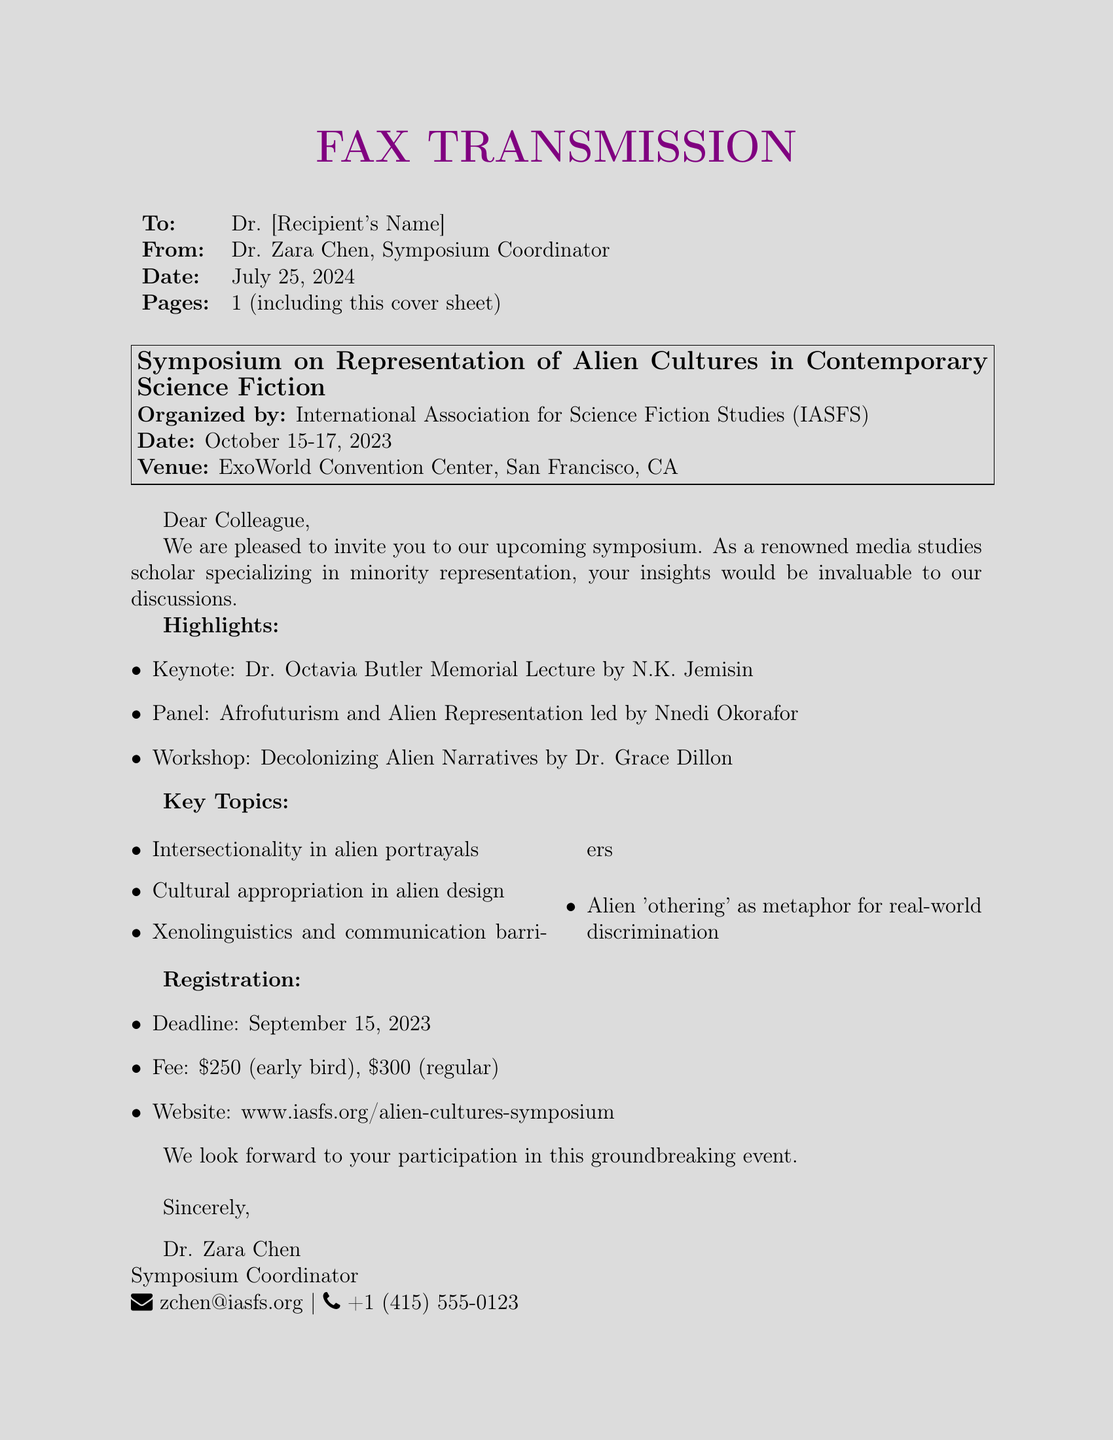What is the date of the symposium? The date of the symposium is specifically mentioned in the document as October 15-17, 2023.
Answer: October 15-17, 2023 Who is giving the keynote lecture? The document states that the keynote lecture is given by N.K. Jemisin in honor of Dr. Octavia Butler.
Answer: N.K. Jemisin What is the registration deadline? The registration deadline is clearly specified in the document as September 15, 2023.
Answer: September 15, 2023 What is the early bird registration fee? The document lists the early bird registration fee as $250.
Answer: $250 What is one of the key topics discussed during the symposium? The document mentions several key topics, including "Alien 'othering' as metaphor for real-world discrimination."
Answer: Alien 'othering' as metaphor for real-world discrimination Why might Dr. Zara Chen have targeted renowned media studies scholars for invitations? The document explains that insights from renowned media studies scholars, especially those specializing in minority representation, would be invaluable to discussions at the symposium.
Answer: Valuable insights What organization is organizing the symposium? The document indicates that the symposium is organized by the International Association for Science Fiction Studies (IASFS).
Answer: International Association for Science Fiction Studies (IASFS) What venue will the symposium be held at? The venue for the symposium is stated in the document as the ExoWorld Convention Center in San Francisco, CA.
Answer: ExoWorld Convention Center, San Francisco, CA How many pages does the fax consist of? The document specifies that the fax comprises one page, including the cover sheet.
Answer: 1 